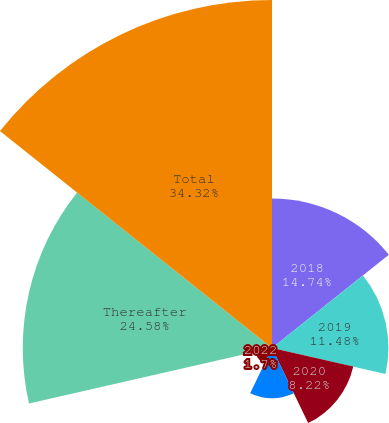<chart> <loc_0><loc_0><loc_500><loc_500><pie_chart><fcel>2018<fcel>2019<fcel>2020<fcel>2021<fcel>2022<fcel>Thereafter<fcel>Total<nl><fcel>14.74%<fcel>11.48%<fcel>8.22%<fcel>4.96%<fcel>1.7%<fcel>24.58%<fcel>34.32%<nl></chart> 